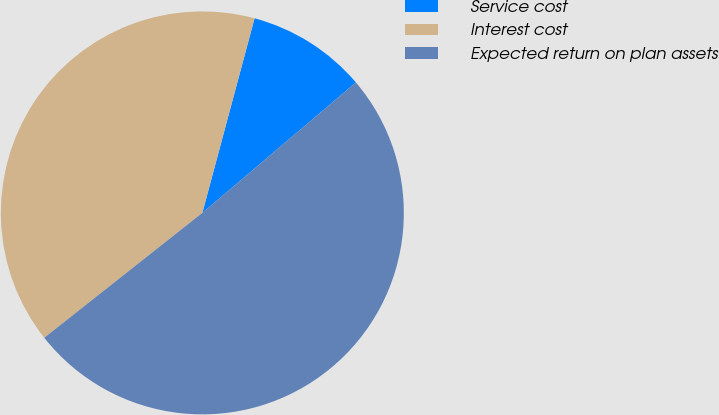<chart> <loc_0><loc_0><loc_500><loc_500><pie_chart><fcel>Service cost<fcel>Interest cost<fcel>Expected return on plan assets<nl><fcel>9.62%<fcel>39.81%<fcel>50.56%<nl></chart> 